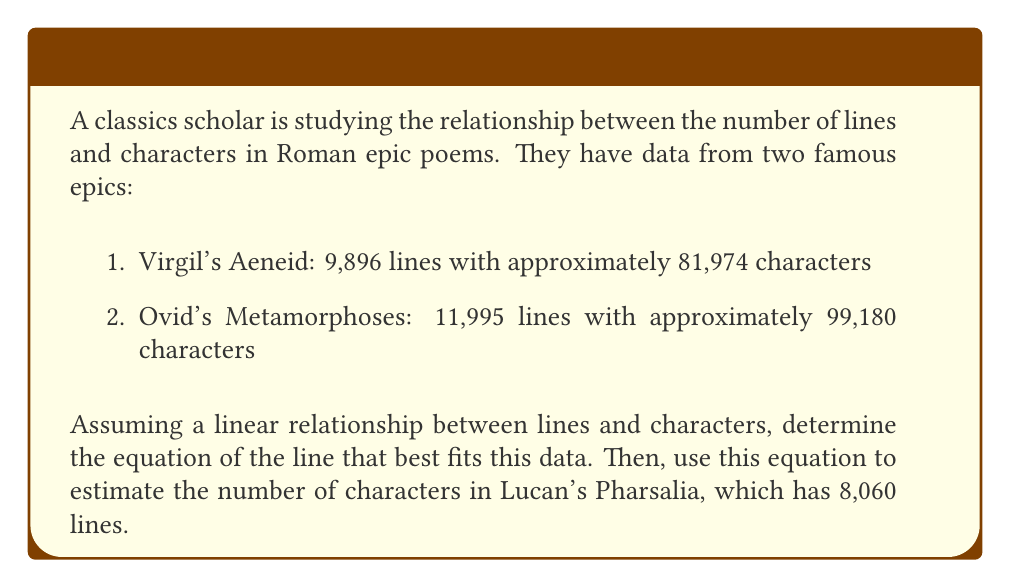Solve this math problem. To solve this problem, we'll use the linear equation $y = mx + b$, where $y$ represents the number of characters, $x$ represents the number of lines, $m$ is the slope, and $b$ is the y-intercept.

1. Calculate the slope (m):
   $$m = \frac{y_2 - y_1}{x_2 - x_1} = \frac{99180 - 81974}{11995 - 9896} = \frac{17206}{2099} \approx 8.1972$$

2. Use the point-slope form of a line to find the y-intercept (b):
   $$y - y_1 = m(x - x_1)$$
   $$81974 = 8.1972(9896) + b$$
   $$b = 81974 - 81124.8512 = 849.1488$$

3. The equation of the line is:
   $$y = 8.1972x + 849.1488$$

4. To estimate the number of characters in Lucan's Pharsalia:
   $$y = 8.1972(8060) + 849.1488 = 66,948.2272$$
Answer: The linear equation relating lines to characters is $y = 8.1972x + 849.1488$, where $y$ is the number of characters and $x$ is the number of lines. Using this equation, Lucan's Pharsalia is estimated to have approximately 66,948 characters. 